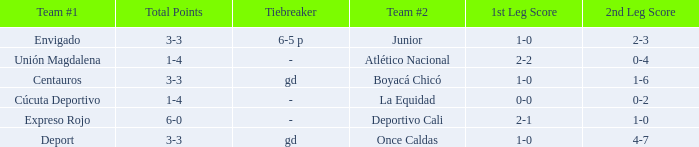What is the 2nd leg for the team #2 junior? 2–3. 